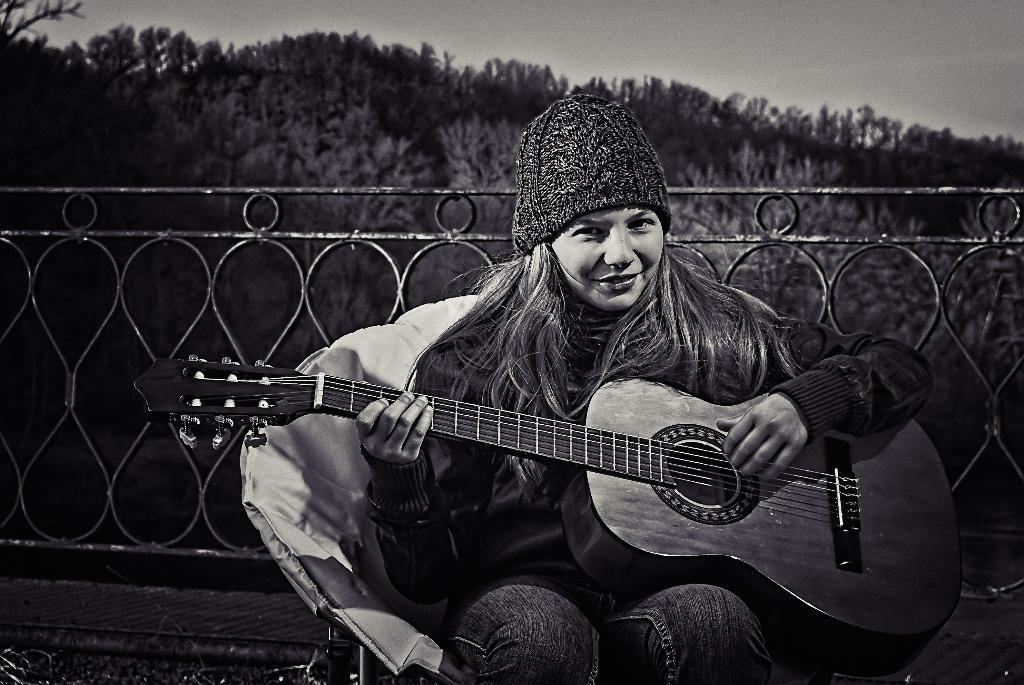Who is the main subject in the image? There is a lady in the image. What is the lady doing in the image? The lady is sitting in the image. What is the lady holding in her hands? The lady is holding a guitar in her hands. What can be seen in the background of the image? There is a railing and trees in the background of the image. What type of education is the lady pursuing in the image? There is no indication of the lady pursuing any education in the image. How quiet is the environment in the image? The image does not provide any information about the noise level or quietness of the environment. 